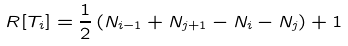Convert formula to latex. <formula><loc_0><loc_0><loc_500><loc_500>R [ T _ { i } ] = \frac { 1 } { 2 } \left ( N _ { i - 1 } + N _ { j + 1 } - N _ { i } - N _ { j } \right ) + 1</formula> 